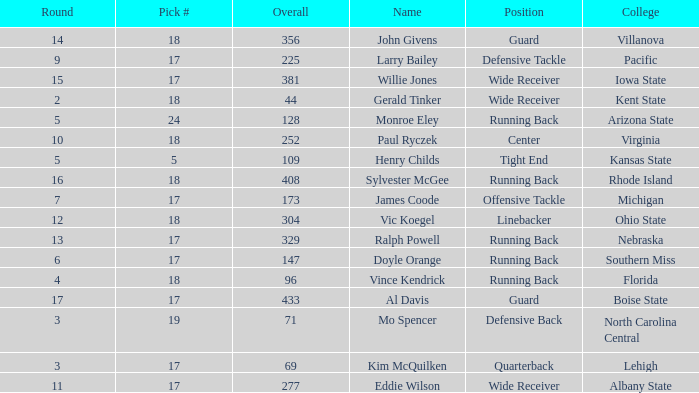Name the total number of round for wide receiver for kent state 1.0. 